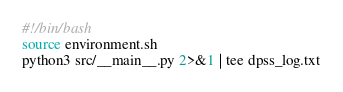Convert code to text. <code><loc_0><loc_0><loc_500><loc_500><_Bash_>#!/bin/bash
source environment.sh
python3 src/__main__.py 2>&1 | tee dpss_log.txt
</code> 